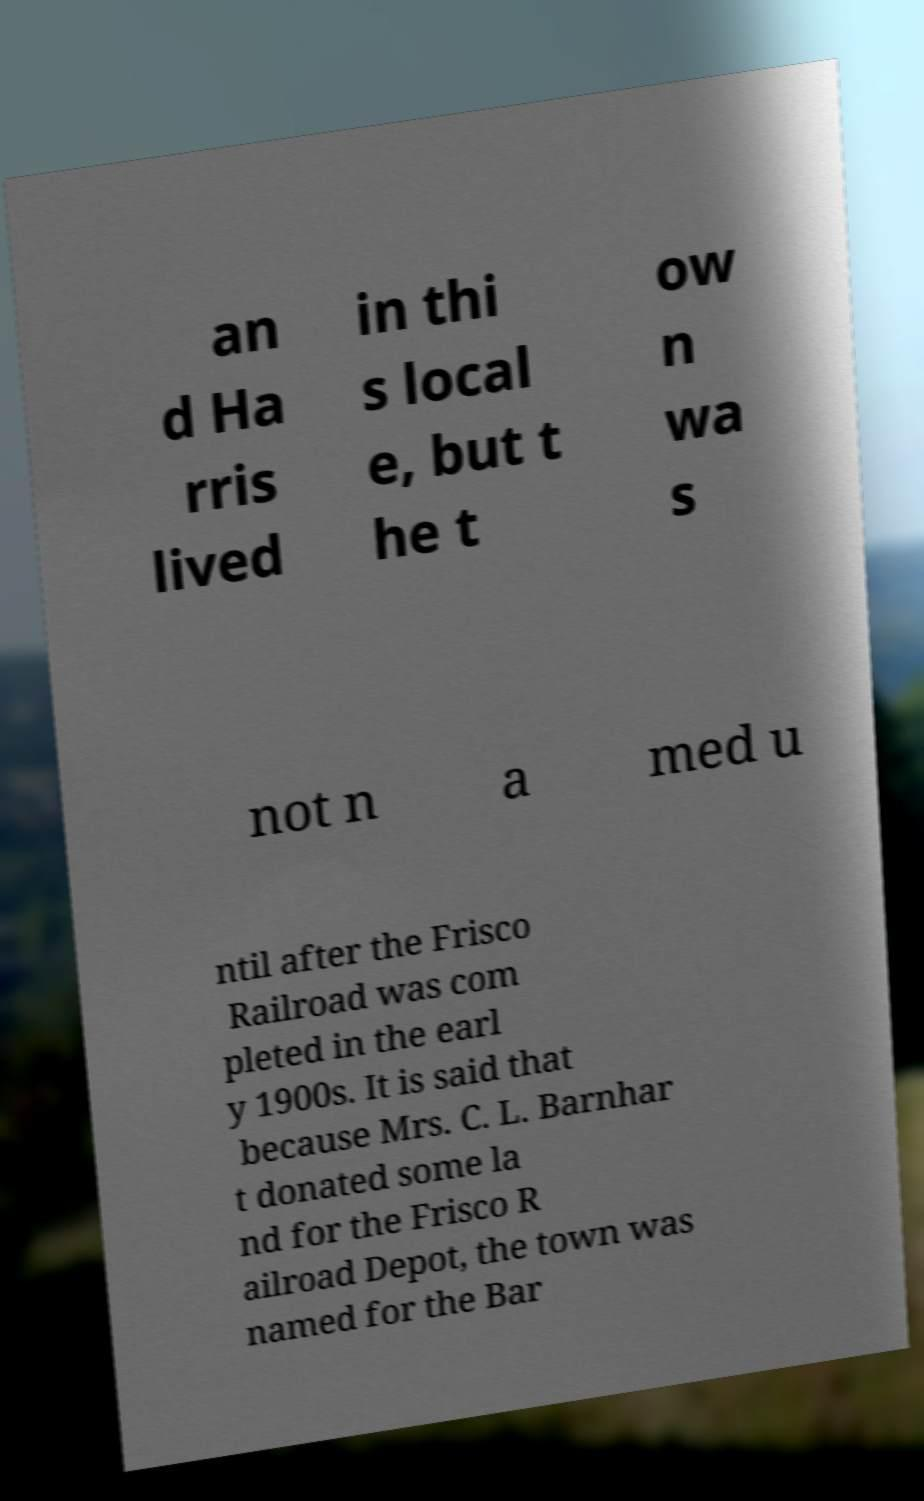I need the written content from this picture converted into text. Can you do that? an d Ha rris lived in thi s local e, but t he t ow n wa s not n a med u ntil after the Frisco Railroad was com pleted in the earl y 1900s. It is said that because Mrs. C. L. Barnhar t donated some la nd for the Frisco R ailroad Depot, the town was named for the Bar 